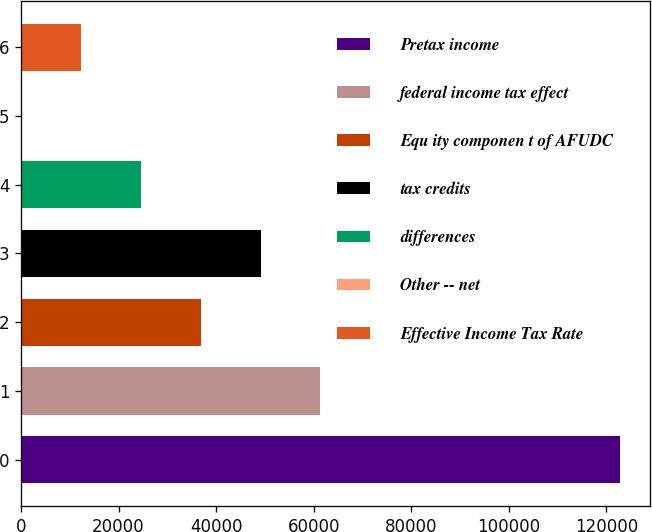<chart> <loc_0><loc_0><loc_500><loc_500><bar_chart><fcel>Pretax income<fcel>federal income tax effect<fcel>Equ ity componen t of AFUDC<fcel>tax credits<fcel>differences<fcel>Other -- net<fcel>Effective Income Tax Rate<nl><fcel>122762<fcel>61384.5<fcel>36833.5<fcel>49109<fcel>24558<fcel>7<fcel>12282.5<nl></chart> 